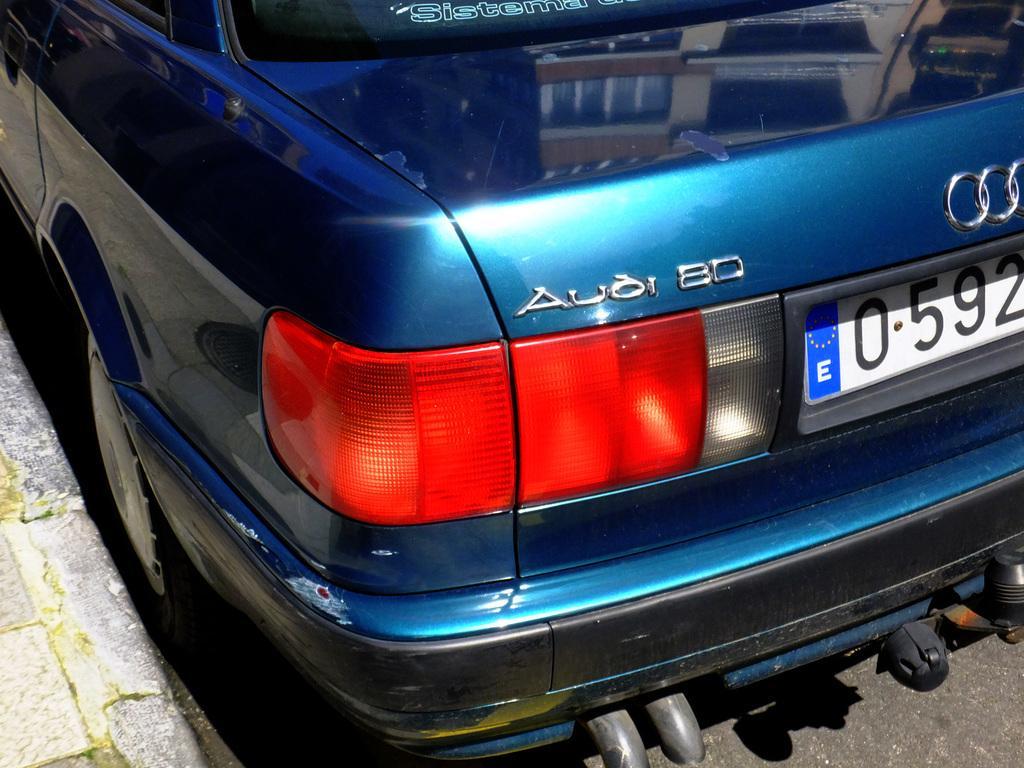Describe this image in one or two sentences. In the picture the boot of an Audi car is visible in the image,the car is kept beside the footpath and it is of blue color. 